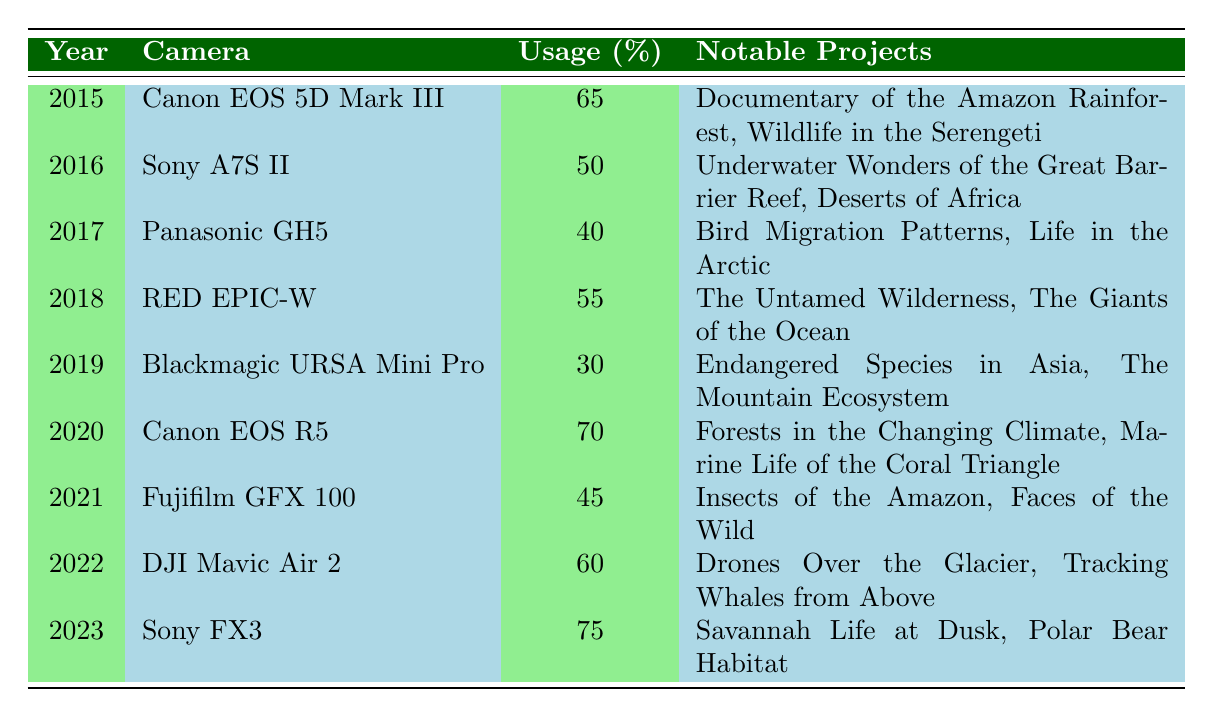What was the camera with the highest percentage usage in 2023? In the table, under the year 2023, the camera used was the Sony FX3, which had a percentage usage of 75.
Answer: Sony FX3 Which year had the lowest percentage usage of equipment? By reviewing the percentage usage column, 2019 has the lowest percentage at 30 with the Blackmagic URSA Mini Pro.
Answer: 2019 What is the average percentage usage of cameras from 2015 to 2022? To find the average, add the percentages for each year from 2015 to 2022: (65 + 50 + 40 + 55 + 30 + 70 + 45 + 60) = 415. There are 8 data points, so the average is 415/8 = 51.875.
Answer: 51.875 Did any projects from 2016 include underwater filming? The notable projects listed for 2016 involved underwater filming, specifically "Underwater Wonders of the Great Barrier Reef." Thus, the answer is true.
Answer: Yes Which camera was used most frequently in the years listed (2015 to 2023)? By reviewing the list, the Canon EOS 5D Mark III was used in 2015, the Sony A7S II in 2016, the Panasonic GH5 in 2017, the RED EPIC-W in 2018, the Blackmagic URSA Mini Pro in 2019, the Canon EOS R5 in 2020, the Fujifilm GFX 100 in 2021, the DJI Mavic Air 2 in 2022, and the Sony FX3 in 2023. Each camera was used once, so no camera was repeated frequently.
Answer: None Which notable project was filmed using the RED EPIC-W? The notable projects listed for the year 2018, where the RED EPIC-W was used, are "The Untamed Wilderness" and "The Giants of the Ocean."
Answer: The Untamed Wilderness and The Giants of the Ocean What are the differences in camera usage between 2015 and 2020? The percentage usage in 2015 for the Canon EOS 5D Mark III was 65, while in 2020 for the Canon EOS R5, it was 70. The difference is 70 - 65 = 5.
Answer: 5 Which camera was used for filming "Savannah Life at Dusk"? The notable project "Savannah Life at Dusk" was filmed using the Sony FX3 in 2023.
Answer: Sony FX3 In which year was filming with the Blackmagic URSA Mini Pro documented? The Blackmagic URSA Mini Pro was used in 2019, as indicated in the year column of the table.
Answer: 2019 